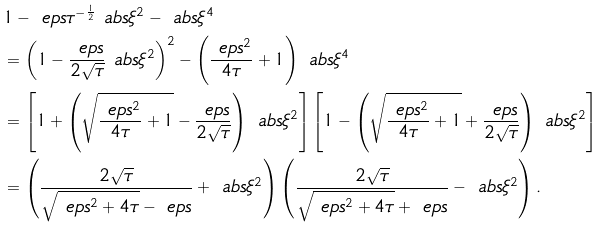<formula> <loc_0><loc_0><loc_500><loc_500>& 1 - \ e p s \tau ^ { - \frac { 1 } { 2 } } \ a b s { \xi } ^ { 2 } - \ a b s { \xi } ^ { 4 } \\ & = \left ( 1 - \frac { \ e p s } { 2 \sqrt { \tau } } \ a b s { \xi } ^ { 2 } \right ) ^ { 2 } - \left ( \frac { \ e p s ^ { 2 } } { 4 \tau } + 1 \right ) \ a b s { \xi } ^ { 4 } \\ & = \left [ 1 + \left ( \sqrt { \frac { \ e p s ^ { 2 } } { 4 \tau } + 1 } - \frac { \ e p s } { 2 \sqrt { \tau } } \right ) \ a b s { \xi } ^ { 2 } \right ] \left [ 1 - \left ( \sqrt { \frac { \ e p s ^ { 2 } } { 4 \tau } + 1 } + \frac { \ e p s } { 2 \sqrt { \tau } } \right ) \ a b s { \xi } ^ { 2 } \right ] \\ & = \left ( \frac { 2 \sqrt { \tau } } { \sqrt { \ e p s ^ { 2 } + 4 \tau } - \ e p s } + \ a b s { \xi } ^ { 2 } \right ) \left ( \frac { 2 \sqrt { \tau } } { \sqrt { \ e p s ^ { 2 } + 4 \tau } + \ e p s } - \ a b s { \xi } ^ { 2 } \right ) .</formula> 